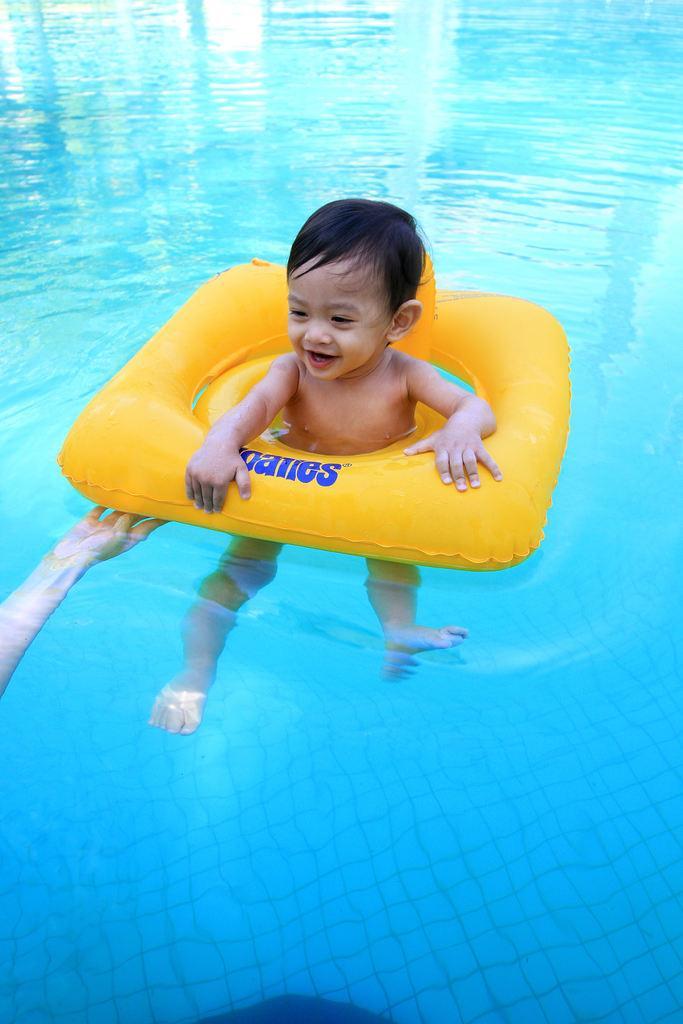Can you describe this image briefly? This image is taken outdoors. In this image there is a swimming pool with water. On the left side of the image there is a person. In the middle of the image there is a kid with a tube in the pool. 